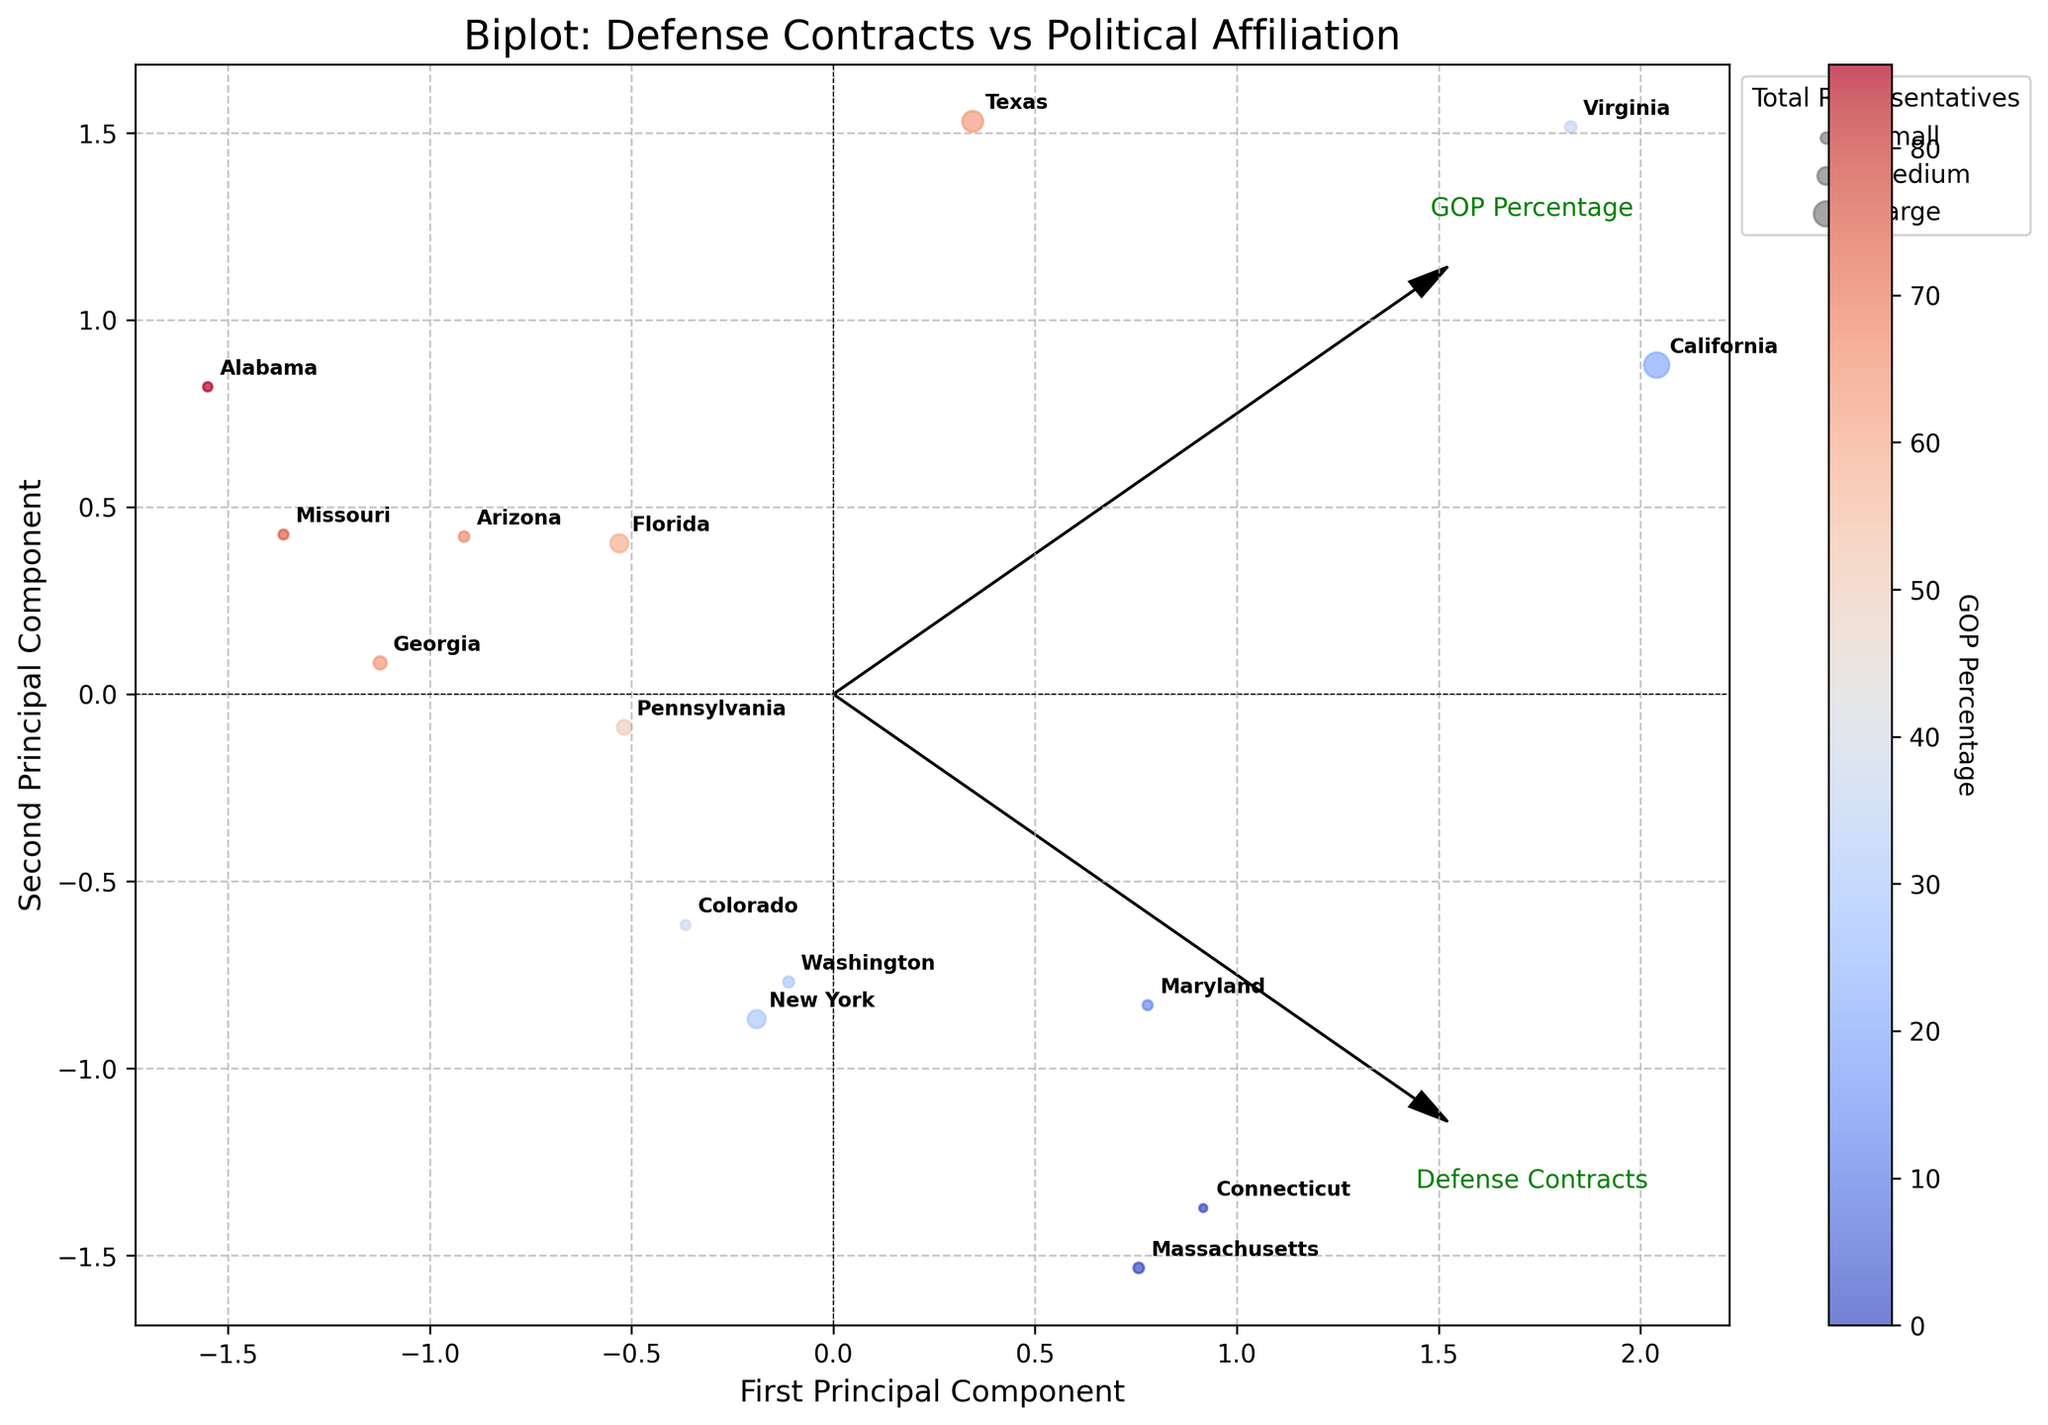What's the title of the plot? The title is prominently displayed at the top of the figure and provides a summary of what the plot is about. In this figure, the title is "Biplot: Defense Contracts vs Political Affiliation".
Answer: Biplot: Defense Contracts vs Political Affiliation How many states are represented in the plot? Each state's data is depicted as a point in the plot, and each point is labeled with the state's name. By counting these labels, we determine there are 15 states represented.
Answer: 15 Which state receives the highest value of defense contracts? The size of the points relates to the total number of representatives, and each state is labeled. The point representing Virginia is both large and positioned farther along the axis representing defense contracts.
Answer: Virginia What does the color scale represent? The color scale shown via the color bar denotes the percentage of GOP (Republican) representation in each state. States with a higher percentage of GOP reps are in warmer colors, and those with a lower percentage are in cooler colors.
Answer: GOP Percentage How does the total number of representatives affect the plot? The plot uses different point sizes to represent the total number of representatives for each state. Larger points indicate a higher number of total representatives. For example, California and Texas, having many representatives, are shown with larger points.
Answer: Larger points indicate more representatives What relationship is shown between defense contracts and GOP percentage? The arrows labeled "Defense Contracts" and "GOP Percentage" show the direction of principal components. By observing the correlation between point positions and arrow directions, a negative correlation is seen where higher values of defense contracts generally correspond to lower GOP percentages, except for a few exceptions.
Answer: A general negative correlation Which state has the lowest percentage of GOP representatives? The point representing Massachusetts is in a blue shade (coolest color) and is labeled, indicating it has a lower GOP percentage. The figure confirms it by color-coding.
Answer: Massachusetts Which state has an equal number of Republican and Democratic representatives? By checking point labels for balance in color and point size, the state with equal representation is Pennsylvania, shown at the balanced intersection of the gridlines.
Answer: Pennsylvania How are the features 'Defense Contracts' and 'GOP Percentage' visually represented? The axes of the biplot show directional arrows for each feature, with "Defense Contracts" and "GOP Percentage" indicating loadings along the principal components. The length and direction of these arrows indicate the influence and relationship of these features on the data points.
Answer: Arrows indicate loadings How are political affiliations and defense contracts visually correlated in the figure? The scatter points’ positions relative to the direction of the "Defense Contracts" and "GOP Percentage" arrows show that states with higher defense contracts tend not to align with higher GOP percentages, with point clustering more evident in the graphical split.
Answer: Negative correlation with some exceptions 